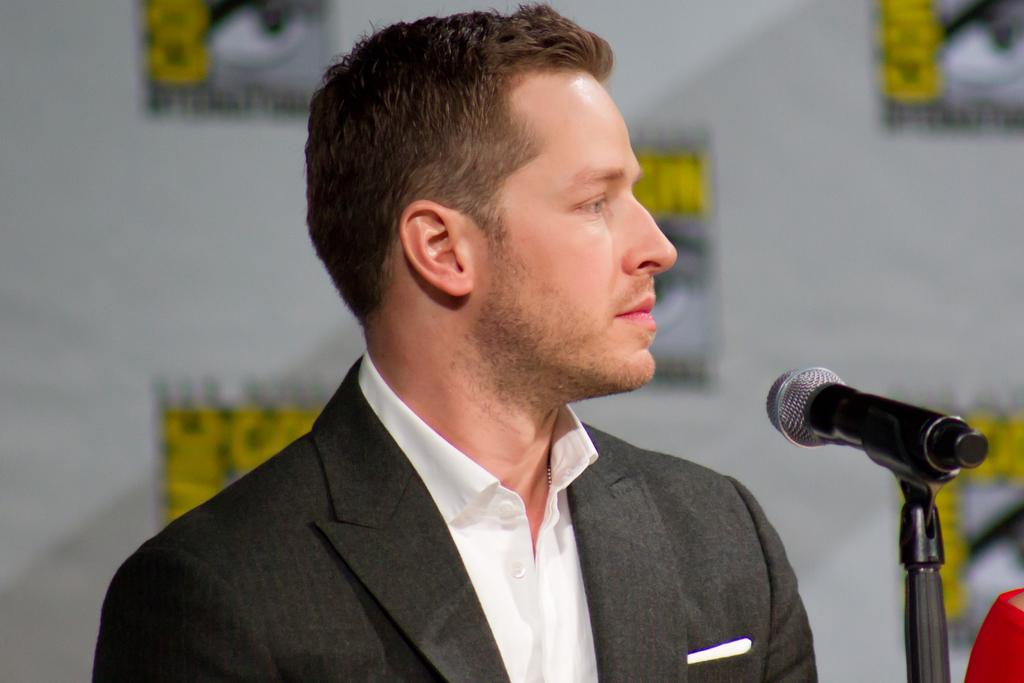What is the man in the image doing? The man is at a mic in the image. Can you describe the mic's position in the image? The mic is on a stand in the image. What is visible in the background of the image? There is a hoarding in the background of the image. What type of skin condition can be seen on the man's face in the image? There is no indication of any skin condition on the man's face in the image. Can you tell me how many cacti are visible in the image? There are no cacti present in the image. 